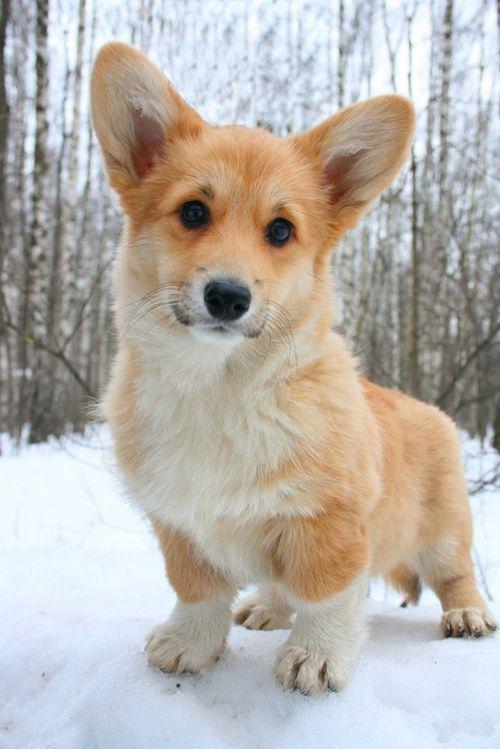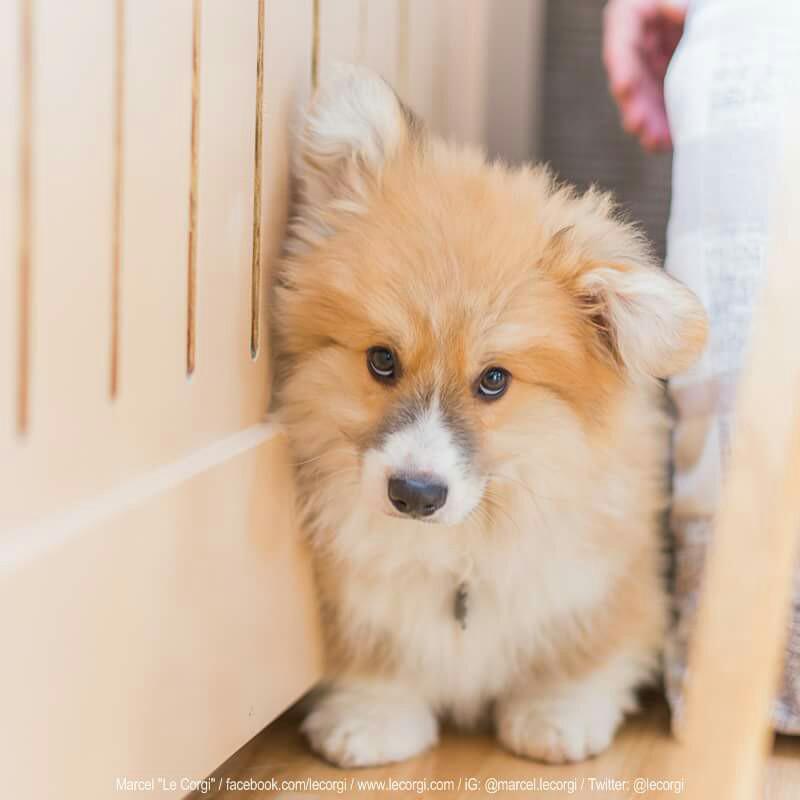The first image is the image on the left, the second image is the image on the right. Analyze the images presented: Is the assertion "One of the dogs is shown with holiday decoration." valid? Answer yes or no. No. The first image is the image on the left, the second image is the image on the right. Given the left and right images, does the statement "One photo shows a dog outdoors." hold true? Answer yes or no. Yes. 